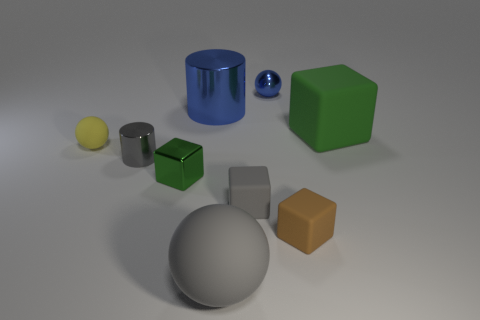How many things are small rubber objects in front of the small green shiny object or large objects that are in front of the tiny brown matte cube?
Make the answer very short. 3. There is a big cube that is in front of the large blue cylinder; is its color the same as the tiny cylinder?
Your answer should be compact. No. How many rubber objects are either green spheres or big things?
Make the answer very short. 2. What is the shape of the tiny gray metallic object?
Your answer should be compact. Cylinder. Are there any other things that are made of the same material as the small cylinder?
Offer a very short reply. Yes. Does the big green cube have the same material as the blue cylinder?
Ensure brevity in your answer.  No. There is a blue metallic object behind the big object behind the green rubber object; is there a gray shiny object that is behind it?
Make the answer very short. No. What number of other objects are there of the same shape as the tiny brown matte object?
Keep it short and to the point. 3. What shape is the matte thing that is in front of the small yellow object and right of the small gray block?
Provide a short and direct response. Cube. The big object in front of the shiny thing that is on the left side of the green cube that is in front of the gray shiny cylinder is what color?
Make the answer very short. Gray. 